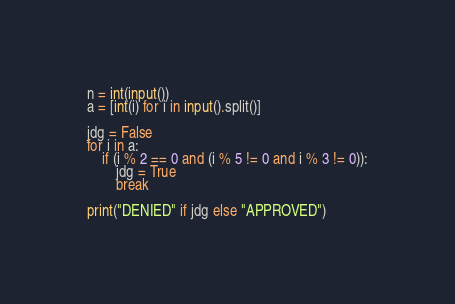<code> <loc_0><loc_0><loc_500><loc_500><_Python_>n = int(input())
a = [int(i) for i in input().split()]

jdg = False
for i in a:
    if (i % 2 == 0 and (i % 5 != 0 and i % 3 != 0)):
        jdg = True
        break

print("DENIED" if jdg else "APPROVED")
</code> 